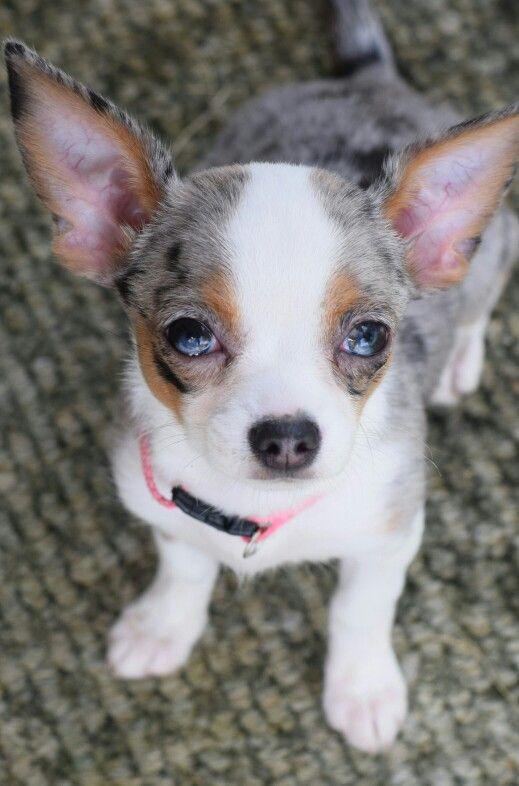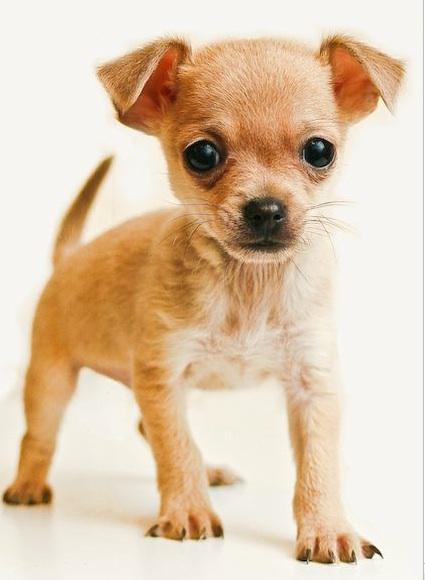The first image is the image on the left, the second image is the image on the right. For the images displayed, is the sentence "At least one of the images features a single dog and shows grass in the image" factually correct? Answer yes or no. No. The first image is the image on the left, the second image is the image on the right. Analyze the images presented: Is the assertion "A leash extends from the small dog in the right-hand image." valid? Answer yes or no. No. 